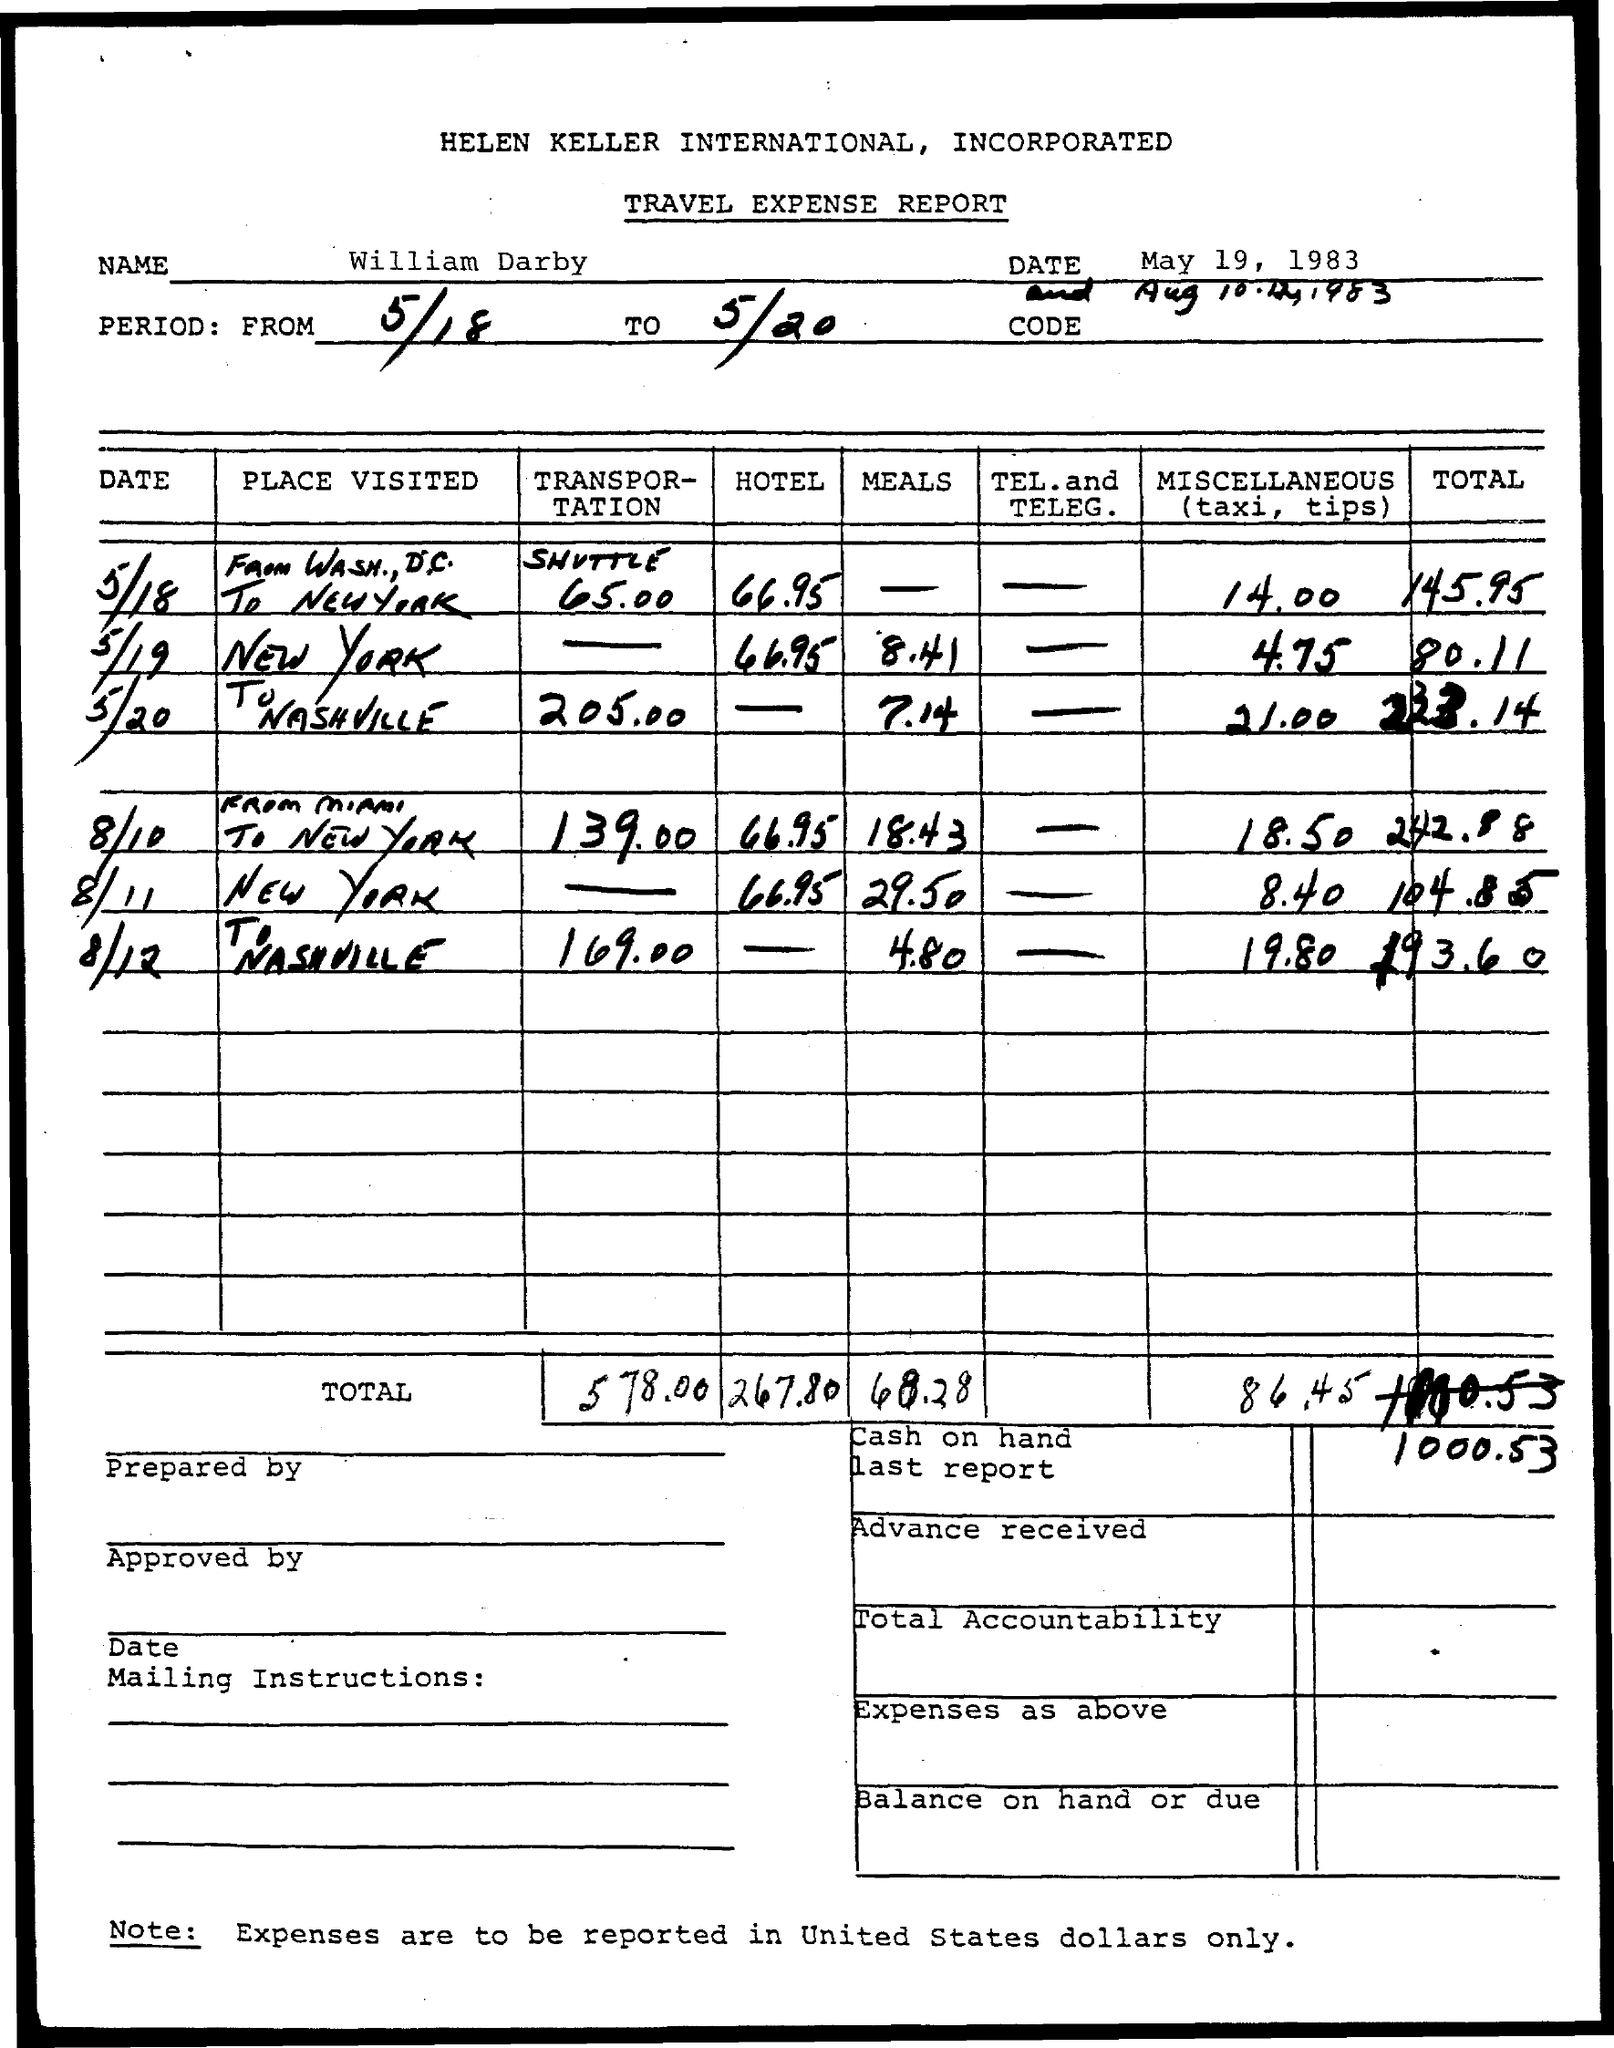What is the name of the person mentioned in the document?
Make the answer very short. William Darby. 